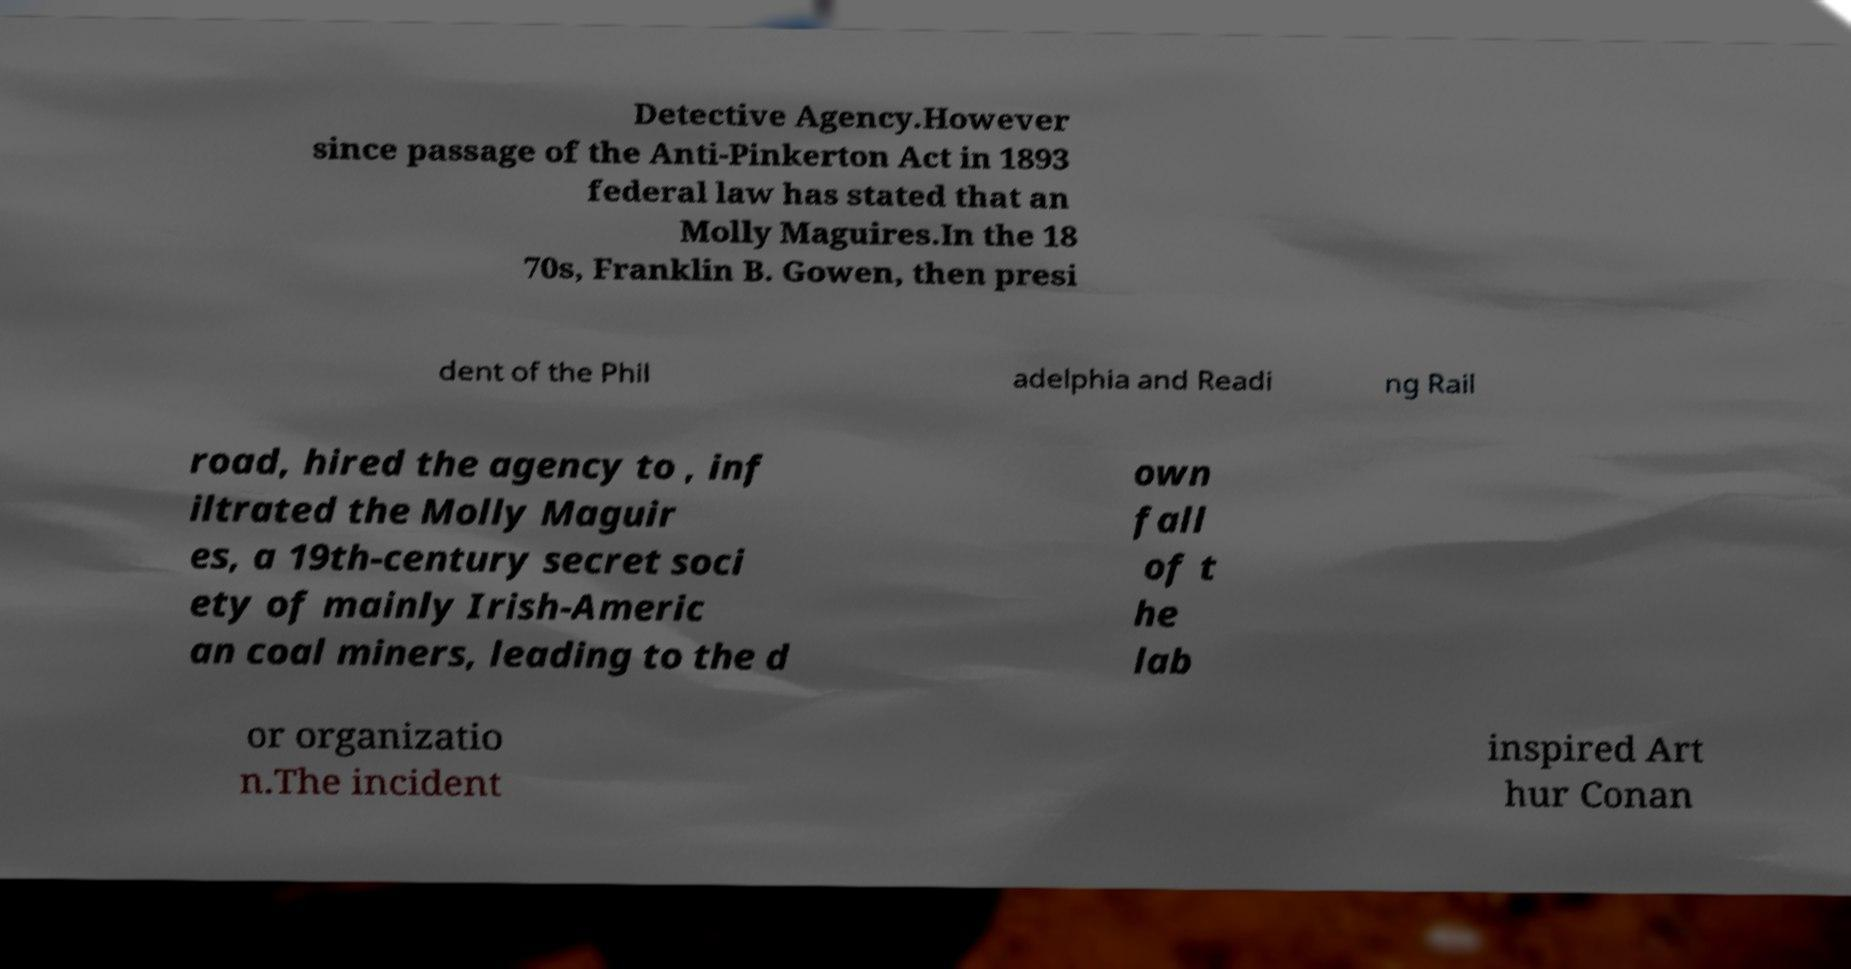I need the written content from this picture converted into text. Can you do that? Detective Agency.However since passage of the Anti-Pinkerton Act in 1893 federal law has stated that an Molly Maguires.In the 18 70s, Franklin B. Gowen, then presi dent of the Phil adelphia and Readi ng Rail road, hired the agency to , inf iltrated the Molly Maguir es, a 19th-century secret soci ety of mainly Irish-Americ an coal miners, leading to the d own fall of t he lab or organizatio n.The incident inspired Art hur Conan 